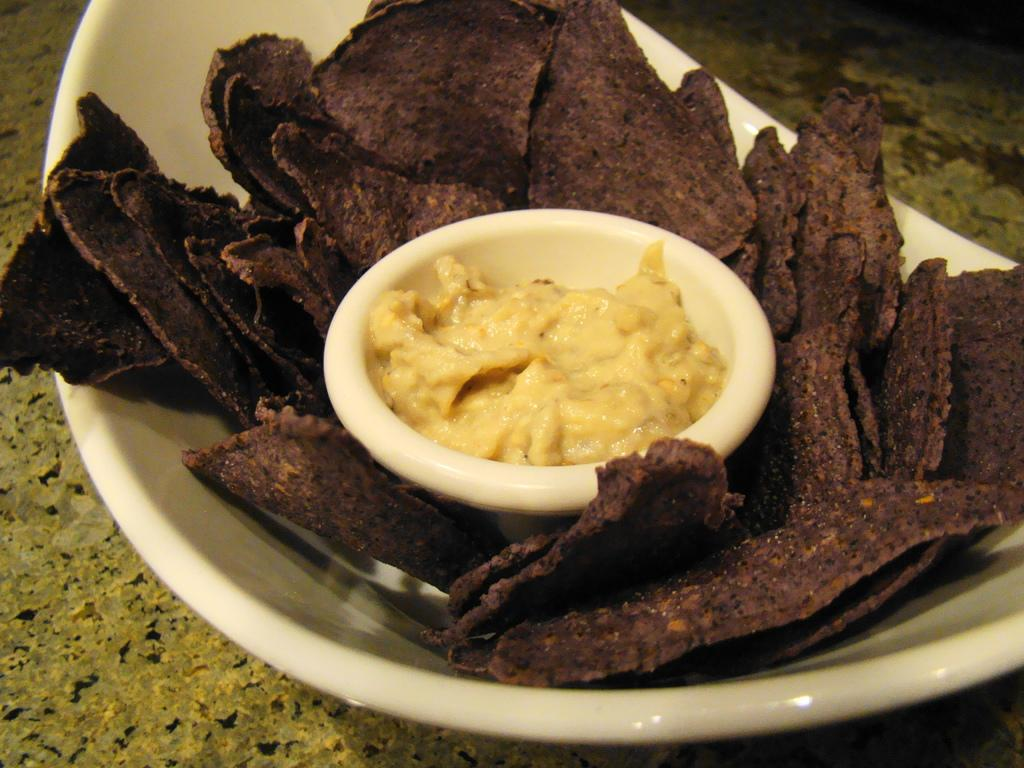What colors are the food in the bowl in the image? The food in the bowl is brown and black. What is the color of the sauce in the small bowl? The sauce in the small bowl is cream-colored. How many passengers are visible in the image? There are no passengers present in the image; it only features food and sauce in bowls. What type of calculator is being used to measure the ingredients in the image? There is no calculator present in the image; it only features food and sauce in bowls. 